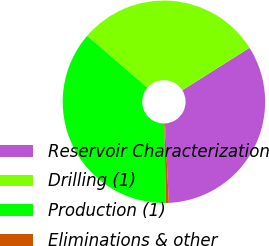<chart> <loc_0><loc_0><loc_500><loc_500><pie_chart><fcel>Reservoir Characterization<fcel>Drilling (1)<fcel>Production (1)<fcel>Eliminations & other<nl><fcel>33.18%<fcel>29.75%<fcel>36.61%<fcel>0.46%<nl></chart> 